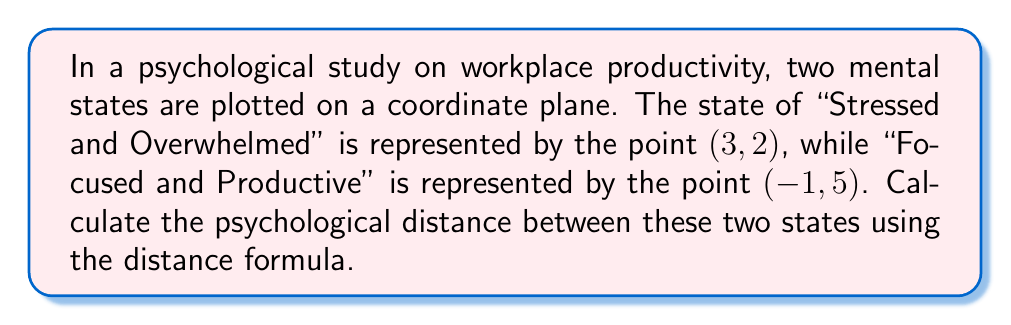Give your solution to this math problem. To solve this problem, we'll use the distance formula, which is derived from the Pythagorean theorem. The distance formula for two points $(x_1, y_1)$ and $(x_2, y_2)$ is:

$$d = \sqrt{(x_2 - x_1)^2 + (y_2 - y_1)^2}$$

Let's assign our points:
- "Stressed and Overwhelmed": $(x_1, y_1) = (3, 2)$
- "Focused and Productive": $(x_2, y_2) = (-1, 5)$

Now, let's substitute these values into the formula:

$$d = \sqrt{(-1 - 3)^2 + (5 - 2)^2}$$

Simplify the expressions inside the parentheses:

$$d = \sqrt{(-4)^2 + (3)^2}$$

Calculate the squares:

$$d = \sqrt{16 + 9}$$

Add the values under the square root:

$$d = \sqrt{25}$$

Simplify the square root:

$$d = 5$$

Therefore, the psychological distance between the two mental states is 5 units on this coordinate plane.

[asy]
import geometry;

size(200);
real xmin = -2, xmax = 4, ymin = 0, ymax = 6;
real xstep = 1, ystep = 1;

// Draw the axes
draw((xmin,0)--(xmax,0), arrow=Arrow());
draw((0,ymin)--(0,ymax), arrow=Arrow());

// Mark the points
dot((3,2), red);
dot((-1,5), blue);

// Label the points
label("(3,2) Stressed", (3,2), SE, red);
label("(-1,5) Focused", (-1,5), NW, blue);

// Draw the line connecting the points
draw((3,2)--(-1,5), dashed);

// Add axis labels
label("x", (xmax,0), E);
label("y", (0,ymax), N);

// Add gridlines
for (real x = xmin+xstep; x < xmax; x += xstep)
  draw((x,ymin)--(x,ymax), gray+0.5);
for (real y = ymin+ystep; y < ymax; y += ystep)
  draw((xmin,y)--(xmax,y), gray+0.5);
[/asy]
Answer: $5$ units 